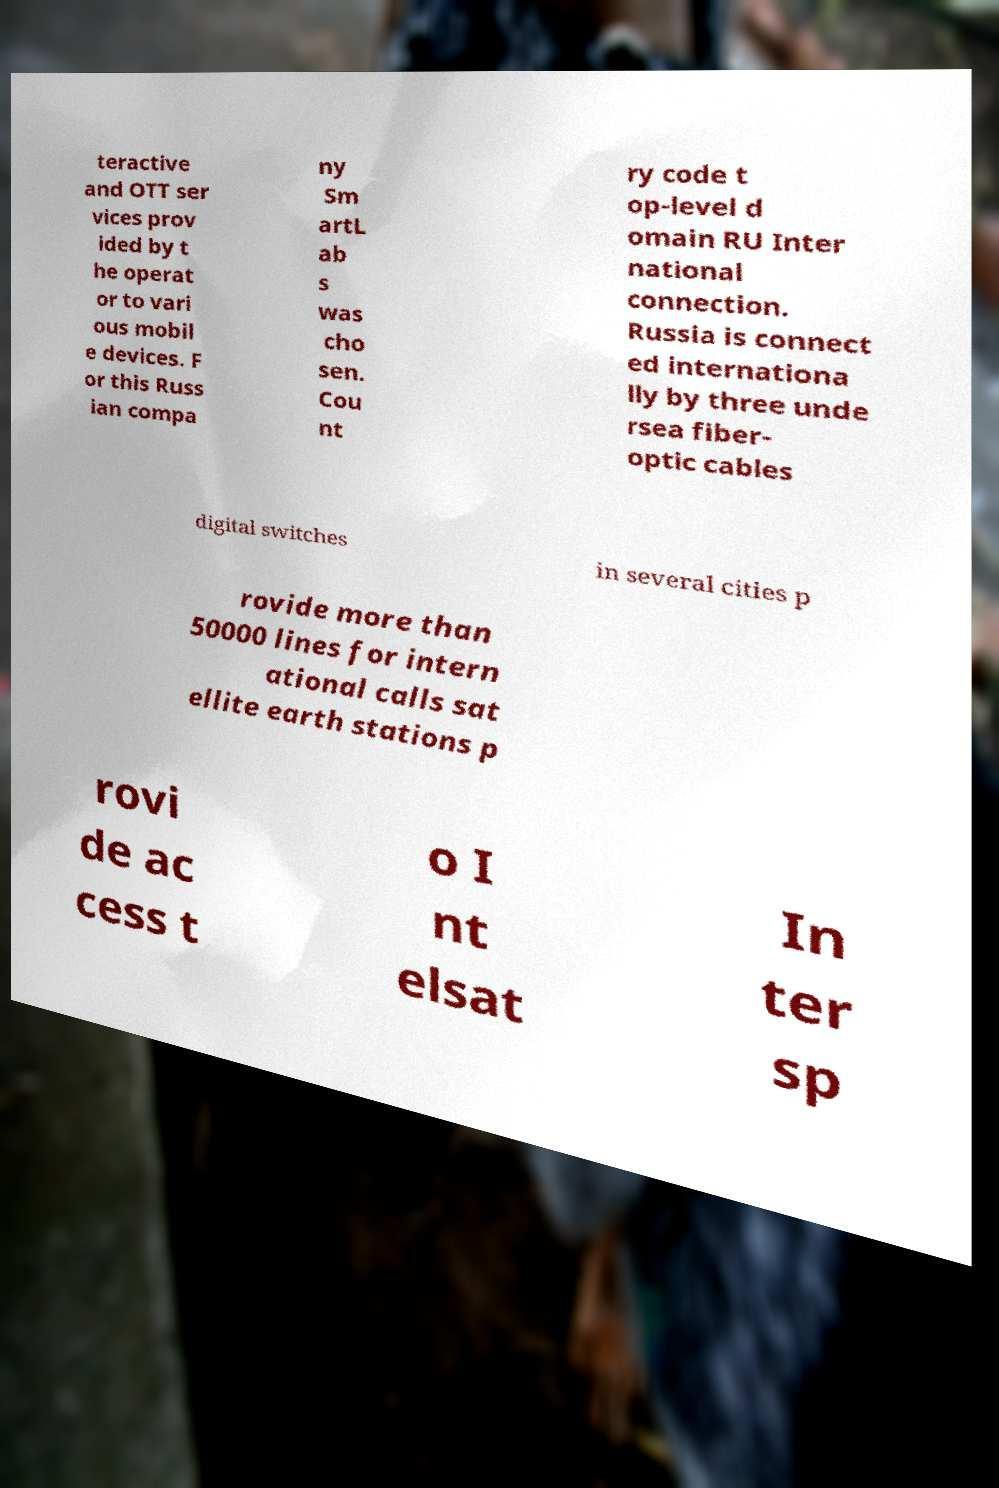Can you accurately transcribe the text from the provided image for me? teractive and OTT ser vices prov ided by t he operat or to vari ous mobil e devices. F or this Russ ian compa ny Sm artL ab s was cho sen. Cou nt ry code t op-level d omain RU Inter national connection. Russia is connect ed internationa lly by three unde rsea fiber- optic cables digital switches in several cities p rovide more than 50000 lines for intern ational calls sat ellite earth stations p rovi de ac cess t o I nt elsat In ter sp 